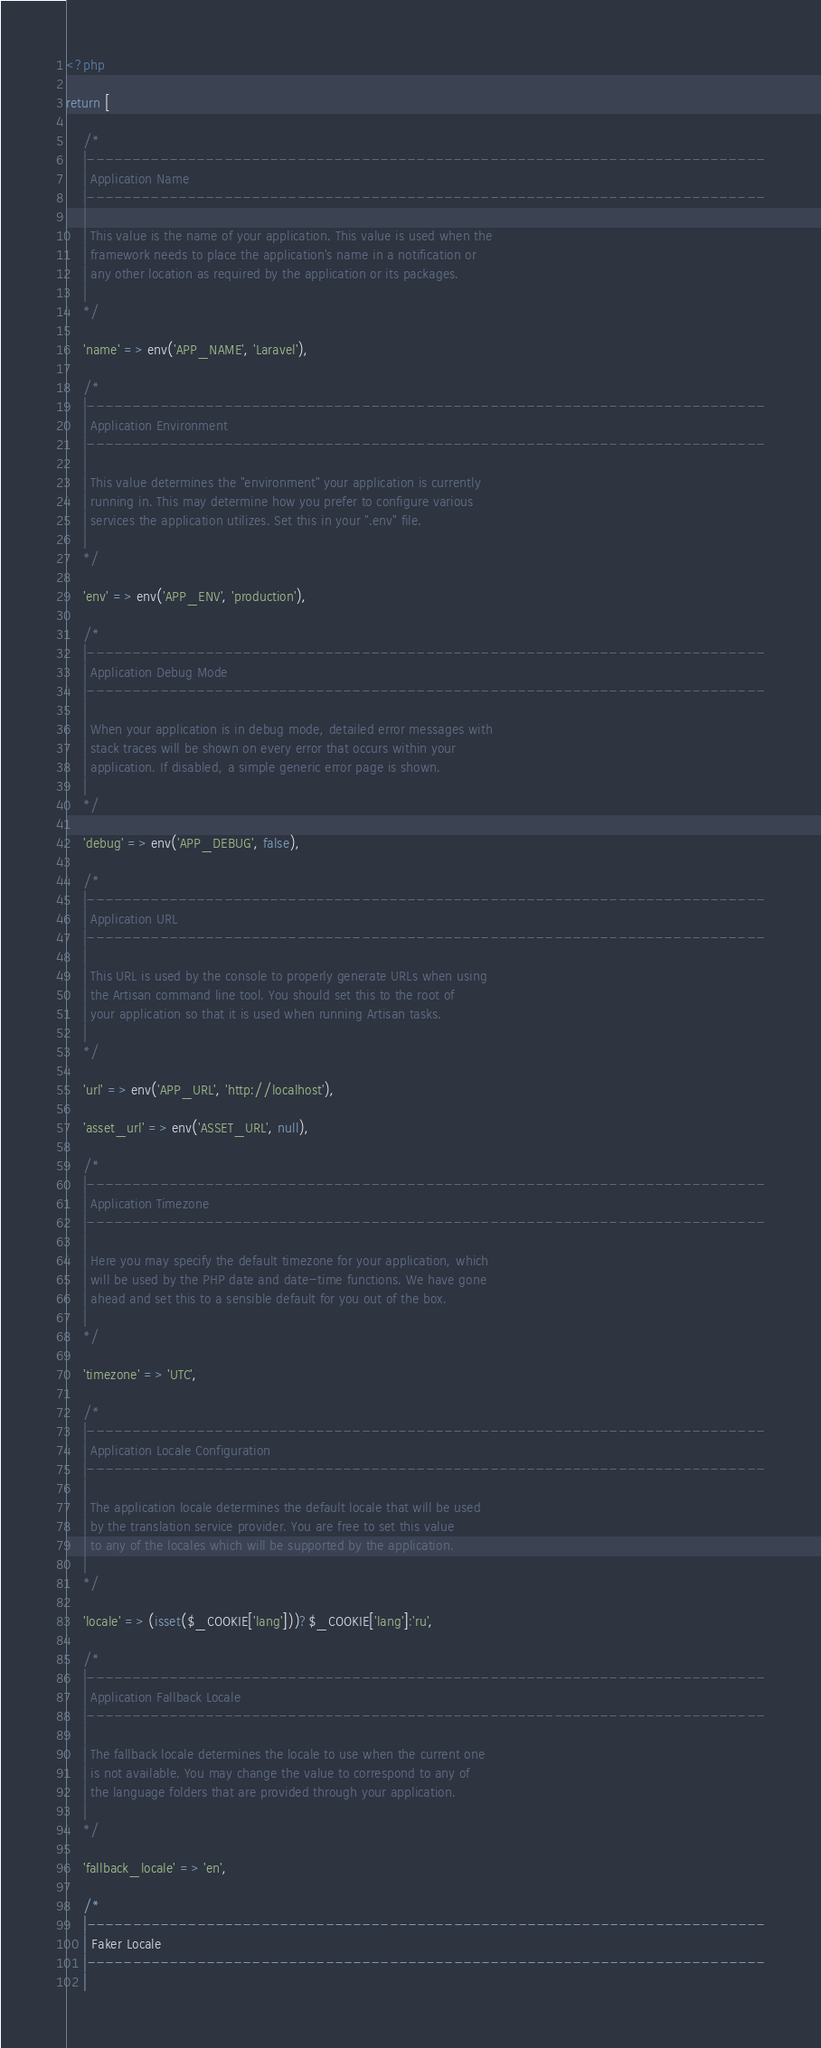<code> <loc_0><loc_0><loc_500><loc_500><_PHP_><?php

return [

    /*
    |--------------------------------------------------------------------------
    | Application Name
    |--------------------------------------------------------------------------
    |
    | This value is the name of your application. This value is used when the
    | framework needs to place the application's name in a notification or
    | any other location as required by the application or its packages.
    |
    */

    'name' => env('APP_NAME', 'Laravel'),

    /*
    |--------------------------------------------------------------------------
    | Application Environment
    |--------------------------------------------------------------------------
    |
    | This value determines the "environment" your application is currently
    | running in. This may determine how you prefer to configure various
    | services the application utilizes. Set this in your ".env" file.
    |
    */

    'env' => env('APP_ENV', 'production'),

    /*
    |--------------------------------------------------------------------------
    | Application Debug Mode
    |--------------------------------------------------------------------------
    |
    | When your application is in debug mode, detailed error messages with
    | stack traces will be shown on every error that occurs within your
    | application. If disabled, a simple generic error page is shown.
    |
    */

    'debug' => env('APP_DEBUG', false),

    /*
    |--------------------------------------------------------------------------
    | Application URL
    |--------------------------------------------------------------------------
    |
    | This URL is used by the console to properly generate URLs when using
    | the Artisan command line tool. You should set this to the root of
    | your application so that it is used when running Artisan tasks.
    |
    */

    'url' => env('APP_URL', 'http://localhost'),

    'asset_url' => env('ASSET_URL', null),

    /*
    |--------------------------------------------------------------------------
    | Application Timezone
    |--------------------------------------------------------------------------
    |
    | Here you may specify the default timezone for your application, which
    | will be used by the PHP date and date-time functions. We have gone
    | ahead and set this to a sensible default for you out of the box.
    |
    */

    'timezone' => 'UTC',

    /*
    |--------------------------------------------------------------------------
    | Application Locale Configuration
    |--------------------------------------------------------------------------
    |
    | The application locale determines the default locale that will be used
    | by the translation service provider. You are free to set this value
    | to any of the locales which will be supported by the application.
    |
    */

    'locale' => (isset($_COOKIE['lang']))?$_COOKIE['lang']:'ru',

    /*
    |--------------------------------------------------------------------------
    | Application Fallback Locale
    |--------------------------------------------------------------------------
    |
    | The fallback locale determines the locale to use when the current one
    | is not available. You may change the value to correspond to any of
    | the language folders that are provided through your application.
    |
    */

    'fallback_locale' => 'en',

    /*
    |--------------------------------------------------------------------------
    | Faker Locale
    |--------------------------------------------------------------------------
    |</code> 